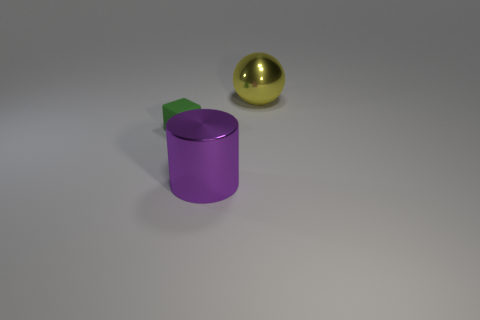Add 3 small green matte things. How many objects exist? 6 Subtract all spheres. How many objects are left? 2 Subtract all large metallic spheres. Subtract all tiny green rubber objects. How many objects are left? 1 Add 1 metallic cylinders. How many metallic cylinders are left? 2 Add 1 large blue things. How many large blue things exist? 1 Subtract 0 green cylinders. How many objects are left? 3 